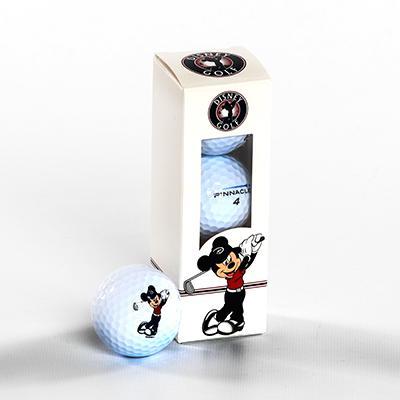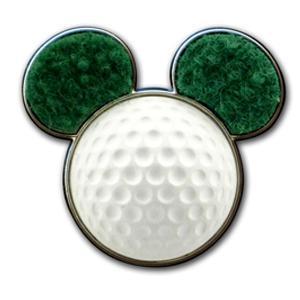The first image is the image on the left, the second image is the image on the right. Given the left and right images, does the statement "One image in the pair contains golf balls inside packaging." hold true? Answer yes or no. Yes. The first image is the image on the left, the second image is the image on the right. Considering the images on both sides, is "There is one golf ball with ears." valid? Answer yes or no. Yes. 